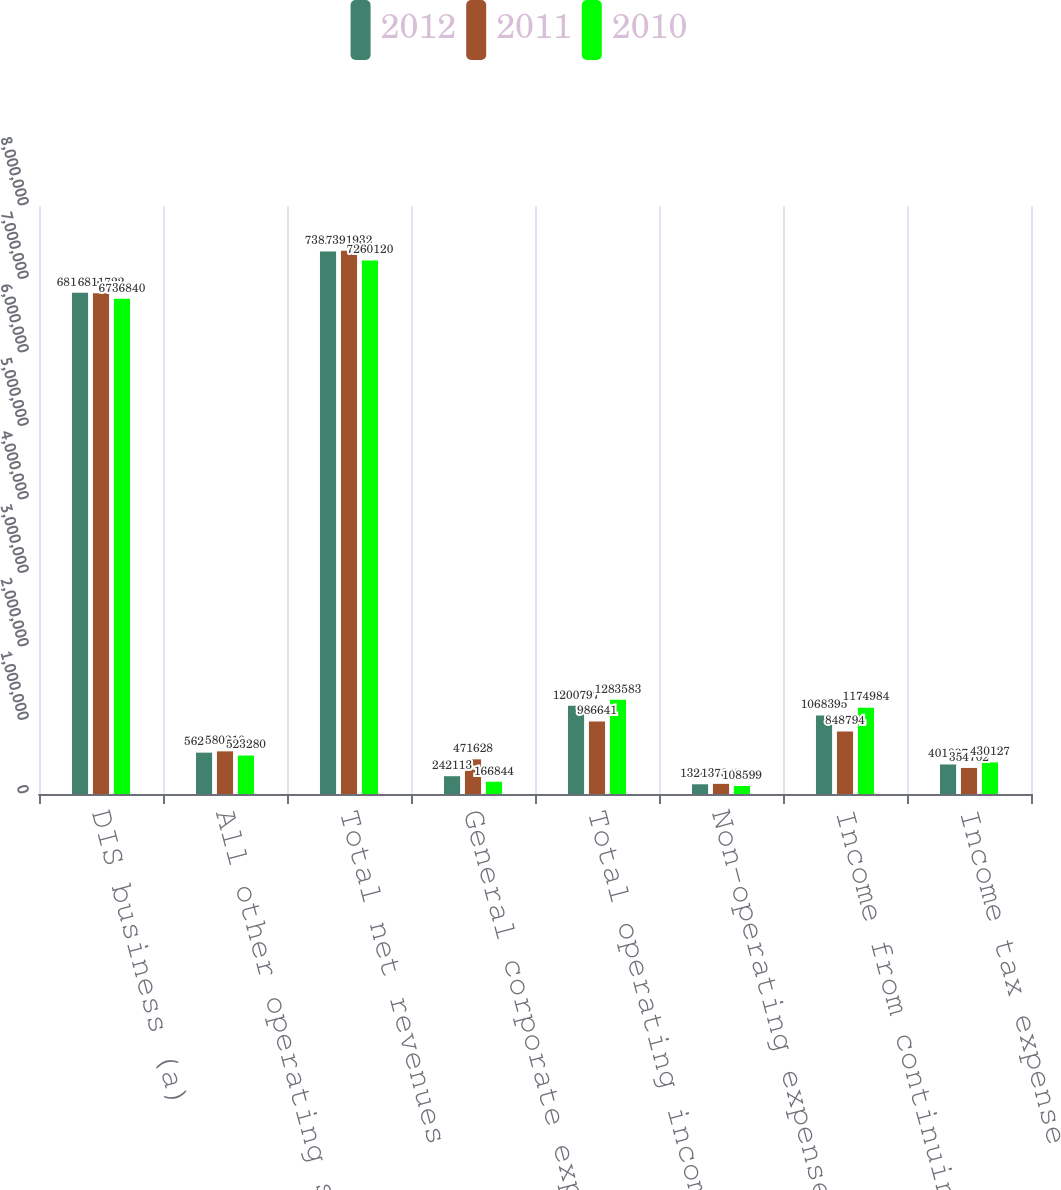<chart> <loc_0><loc_0><loc_500><loc_500><stacked_bar_chart><ecel><fcel>DIS business (a)<fcel>All other operating segments<fcel>Total net revenues<fcel>General corporate expenses<fcel>Total operating income<fcel>Non-operating expenses net<fcel>Income from continuing<fcel>Income tax expense<nl><fcel>2012<fcel>6.81992e+06<fcel>562646<fcel>7.38256e+06<fcel>242113<fcel>1.2008e+06<fcel>132402<fcel>1.0684e+06<fcel>401897<nl><fcel>2011<fcel>6.81172e+06<fcel>580210<fcel>7.39193e+06<fcel>471628<fcel>986641<fcel>137847<fcel>848794<fcel>354702<nl><fcel>2010<fcel>6.73684e+06<fcel>523280<fcel>7.26012e+06<fcel>166844<fcel>1.28358e+06<fcel>108599<fcel>1.17498e+06<fcel>430127<nl></chart> 